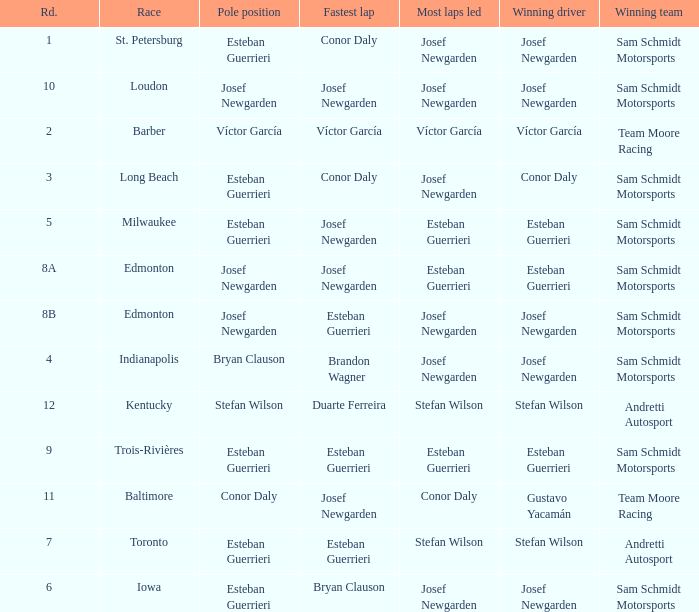Who had the fastest lap(s) when stefan wilson had the pole? Duarte Ferreira. 